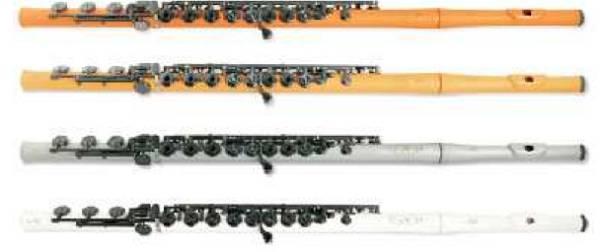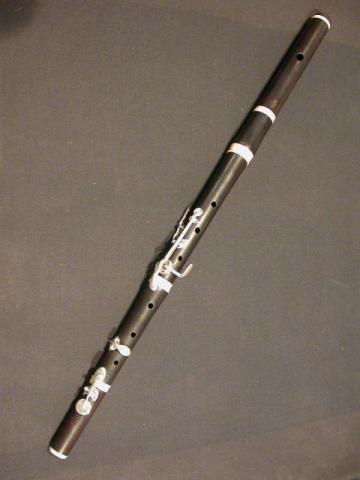The first image is the image on the left, the second image is the image on the right. For the images displayed, is the sentence "No image contains more than one instrument, and one instrument is light wood with holes down its length, and the other is silver with small button-keys on tabs." factually correct? Answer yes or no. No. The first image is the image on the left, the second image is the image on the right. Assess this claim about the two images: "The left image contains at least two musical instruments.". Correct or not? Answer yes or no. Yes. 